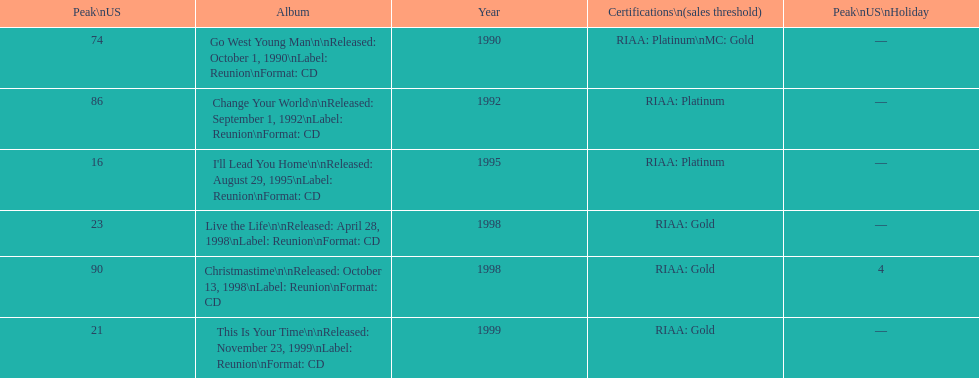What was the first michael w smith album? Go West Young Man. 